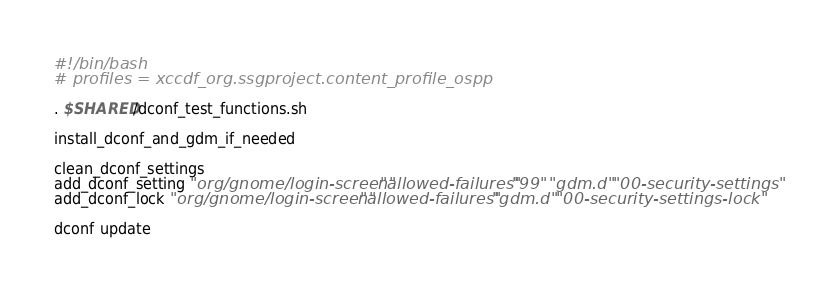<code> <loc_0><loc_0><loc_500><loc_500><_Bash_>#!/bin/bash
# profiles = xccdf_org.ssgproject.content_profile_ospp

. $SHARED/dconf_test_functions.sh

install_dconf_and_gdm_if_needed

clean_dconf_settings
add_dconf_setting "org/gnome/login-screen" "allowed-failures" "99" "gdm.d" "00-security-settings"
add_dconf_lock "org/gnome/login-screen" "allowed-failures" "gdm.d" "00-security-settings-lock"

dconf update
</code> 